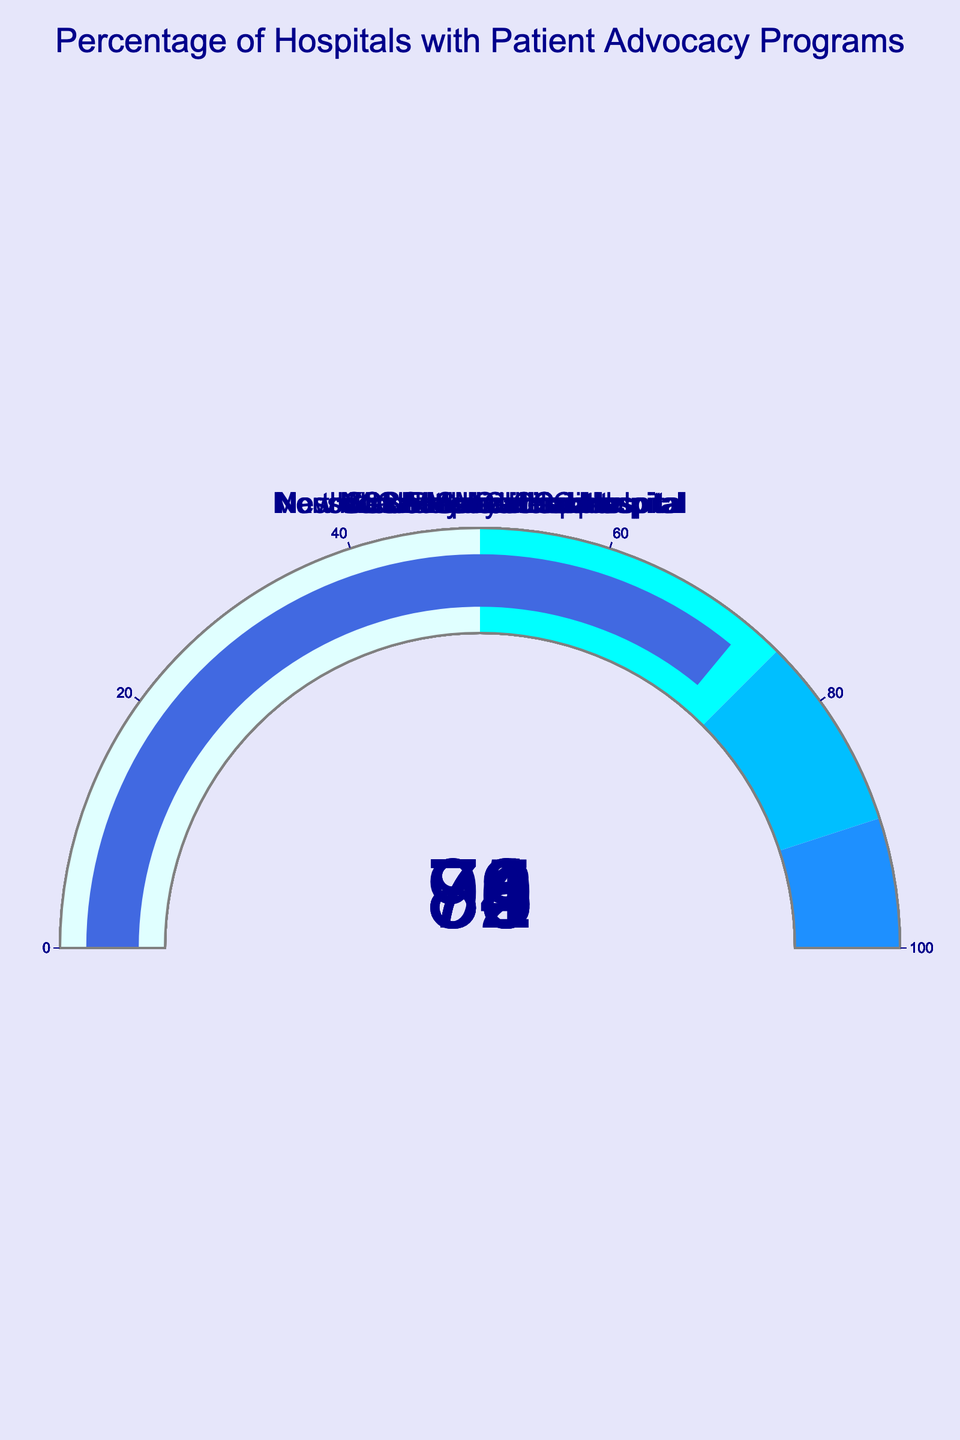What is the percentage of hospitals with patient advocacy programs at Mayo Clinic? The gauge chart for Mayo Clinic shows a specific number in the center which represents the percentage of hospitals with patient advocacy programs.
Answer: 92 Which hospital has the lowest percentage of hospitals with patient advocacy programs? By examining the gauge charts for each hospital, the one displaying the smallest number represents the hospital with the lowest percentage of advocacy programs.
Answer: Northwestern Memorial Hospital What is the total percentage for Massachusetts General Hospital and UCLA Medical Center combined? The percentage for Massachusetts General Hospital is 83 and for UCLA Medical Center is 76. Adding them together gives 83 + 76.
Answer: 159 How many hospitals have a percentage greater than 80? By counting the gauges with values greater than 80, we find Mayo Clinic (92), Cleveland Clinic (88), John Hopkins Hospital (85), Stanford Health Care (81), and Massachusetts General Hospital (83).
Answer: 5 What is the average percentage of hospitals with patient advocacy programs in the list? Sum all percentages: 92 + 88 + 85 + 83 + 79 + 76 + 81 + 74 + 78 + 72 = 808. Divide by the number of hospitals, which is 10: 808 / 10.
Answer: 80.8 Is the percentage for UCSF Medical Center higher or lower than Mount Sinai Hospital? Compare the two percentages: UCSF Medical Center has 78 and Mount Sinai Hospital has 74.
Answer: Higher Which hospitals have a percentage between 75 and 90? Hospitals with values within this range are Johns Hopkins Hospital (85), Massachusetts General Hospital (83), Stanford Health Care (81), UCSF Medical Center (78), and New York-Presbyterian Hospital (79).
Answer: Johns Hopkins Hospital, Massachusetts General Hospital, Stanford Health Care, UCSF Medical Center, New York-Presbyterian Hospital What is the difference between the hospital with the highest and lowest percentage of patient advocacy programs? The highest is Mayo Clinic with 92, and the lowest is Northwestern Memorial Hospital with 72. The difference is 92 - 72.
Answer: 20 